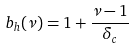<formula> <loc_0><loc_0><loc_500><loc_500>b _ { h } ( \nu ) & = 1 + \frac { \nu - 1 } { \delta _ { c } }</formula> 